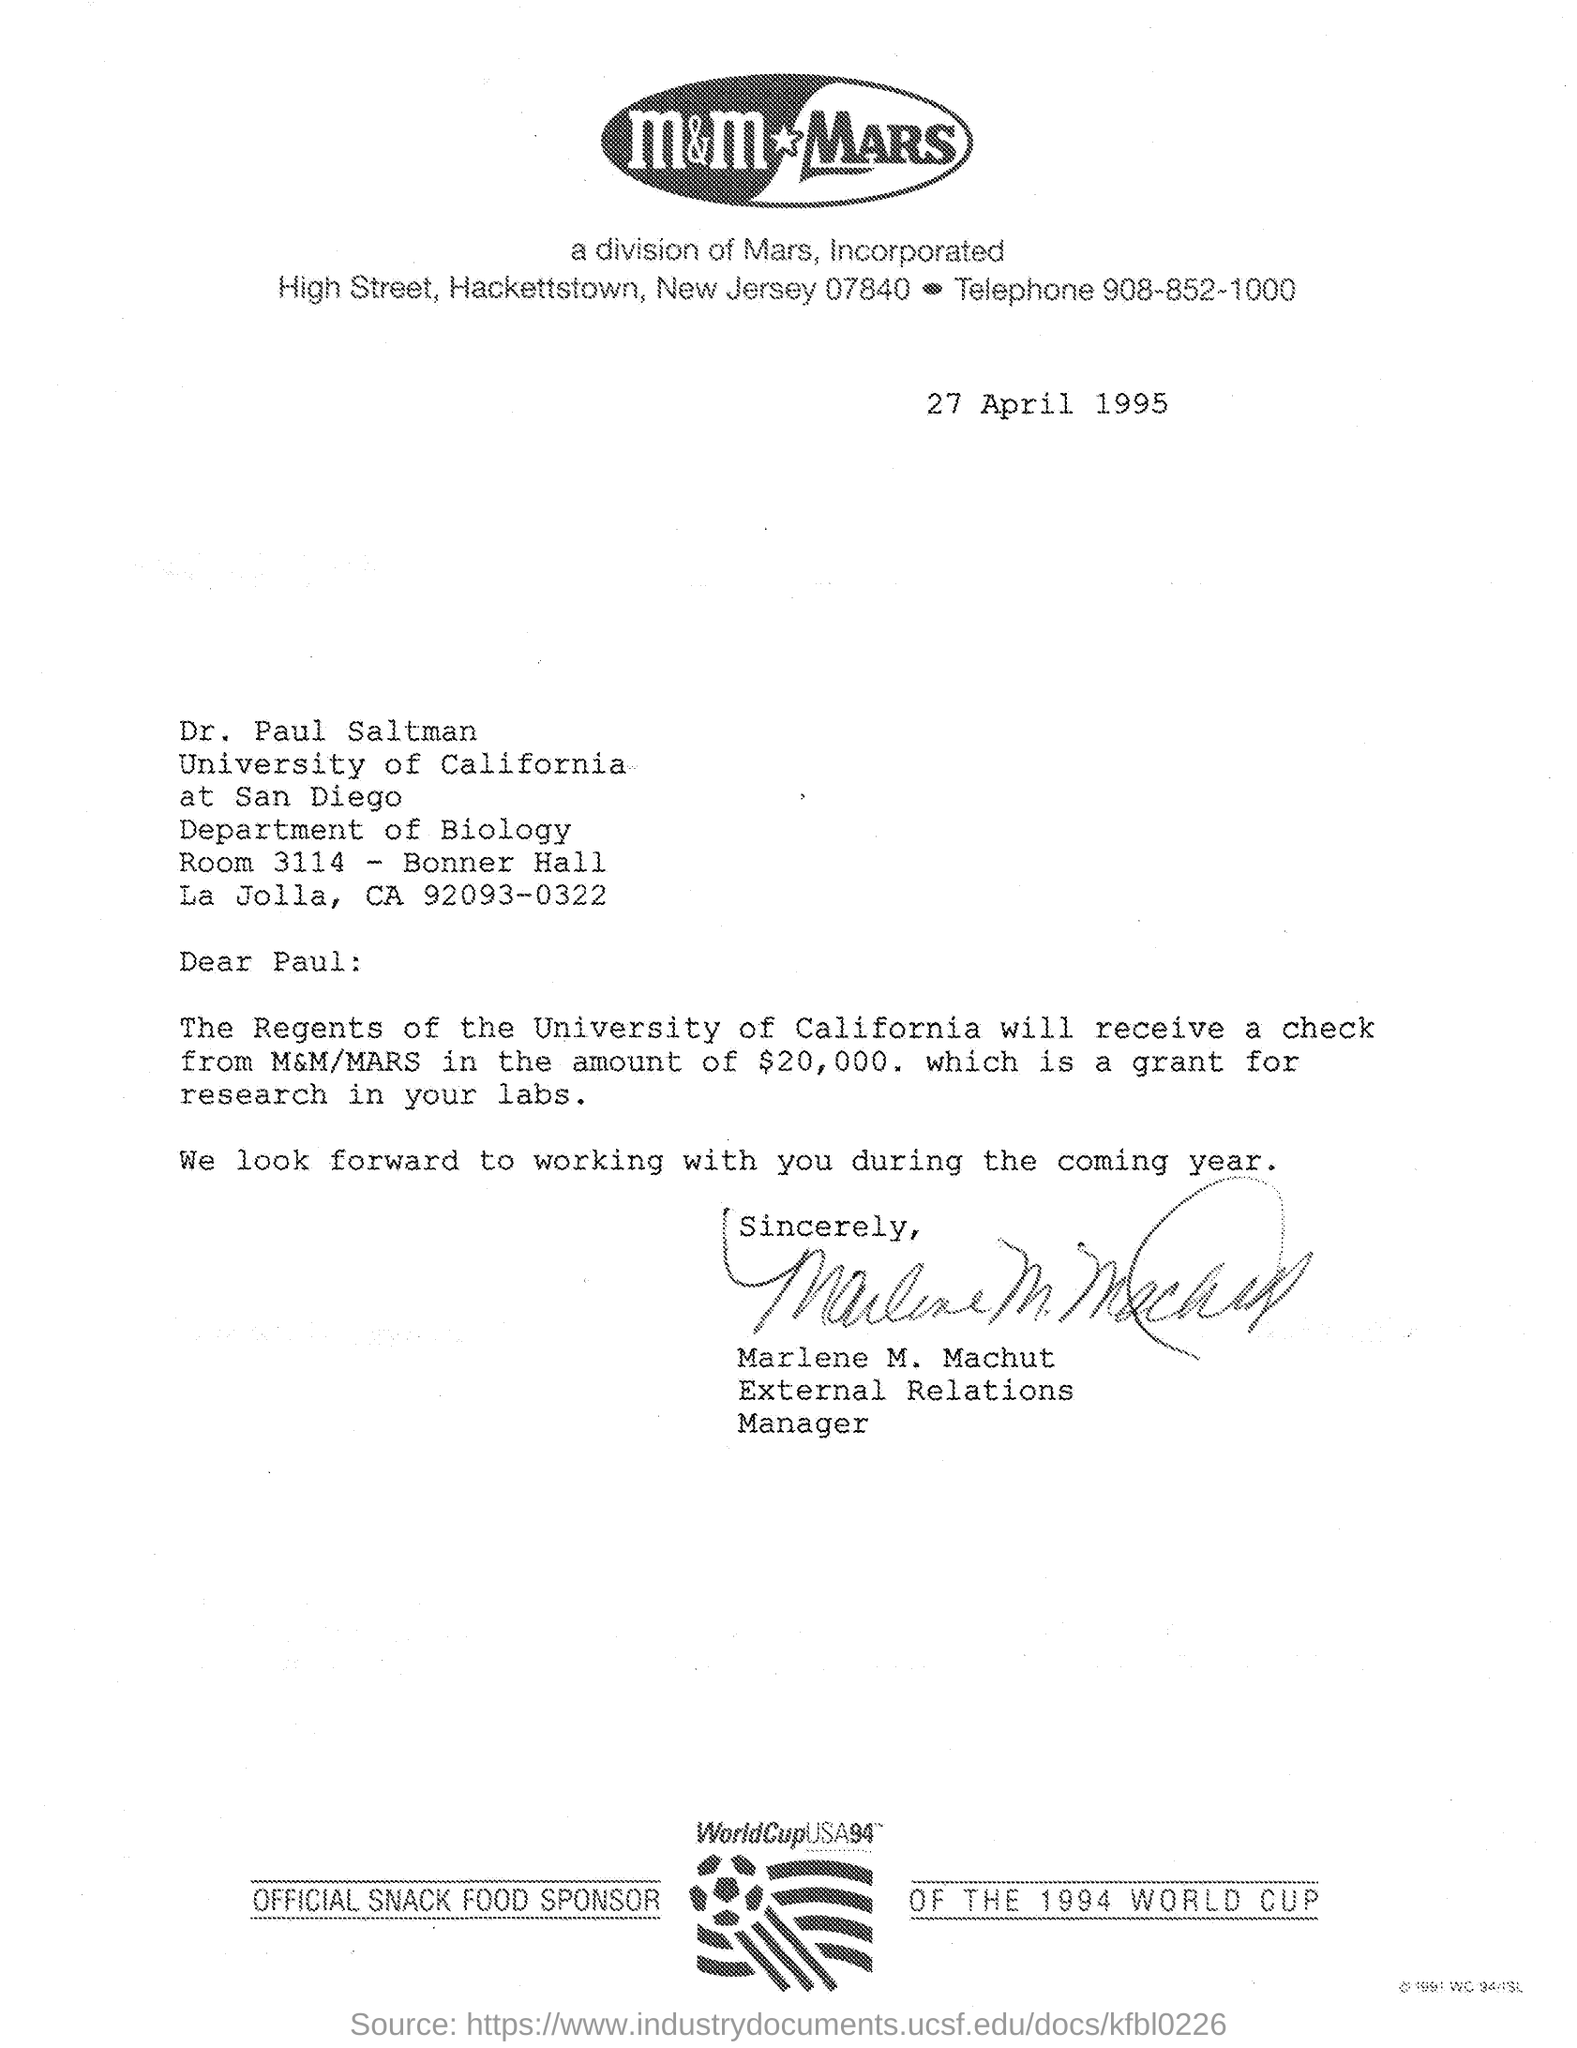What is the telephone number mentioned in the given letter ?
Your response must be concise. 908-852-1000. What is the date mentioned in the given letter ?
Offer a terse response. 27 April 1995. Who's sign was there at the end of the letter ?
Your answer should be very brief. Marlene M. Machut. What is the designation on marlene m. machut as mentioned  in the given letetr ?
Keep it short and to the point. External relations manager. To which university dr. paul salt man belongs to ?
Keep it short and to the point. University of california. What is the name of the department mentioned in the given letter ?
Make the answer very short. Department of biology. 